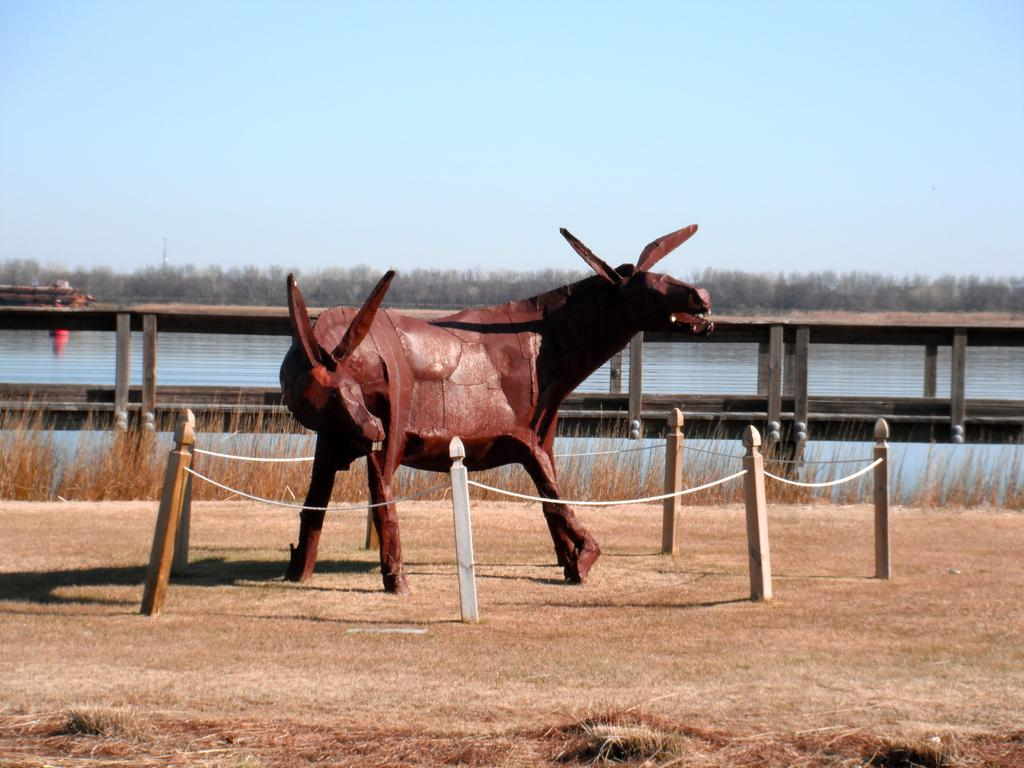What type of statue is in the image? There is a wooden statue of a cow in the image. What is placed in front of the statue? There are rope barriers in the front of the statue. What natural feature can be seen in the image? There is a river with water visible in the image. What type of vegetation is behind the statue? There are dry trees behind the statue. What is visible at the top of the image? The sky is visible at the top of the image. What type of cakes are being served at the goat's birthday party in the image? There is no goat or birthday party present in the image. The image features a wooden statue of a cow, rope barriers, a river, dry trees, and a visible sky. 